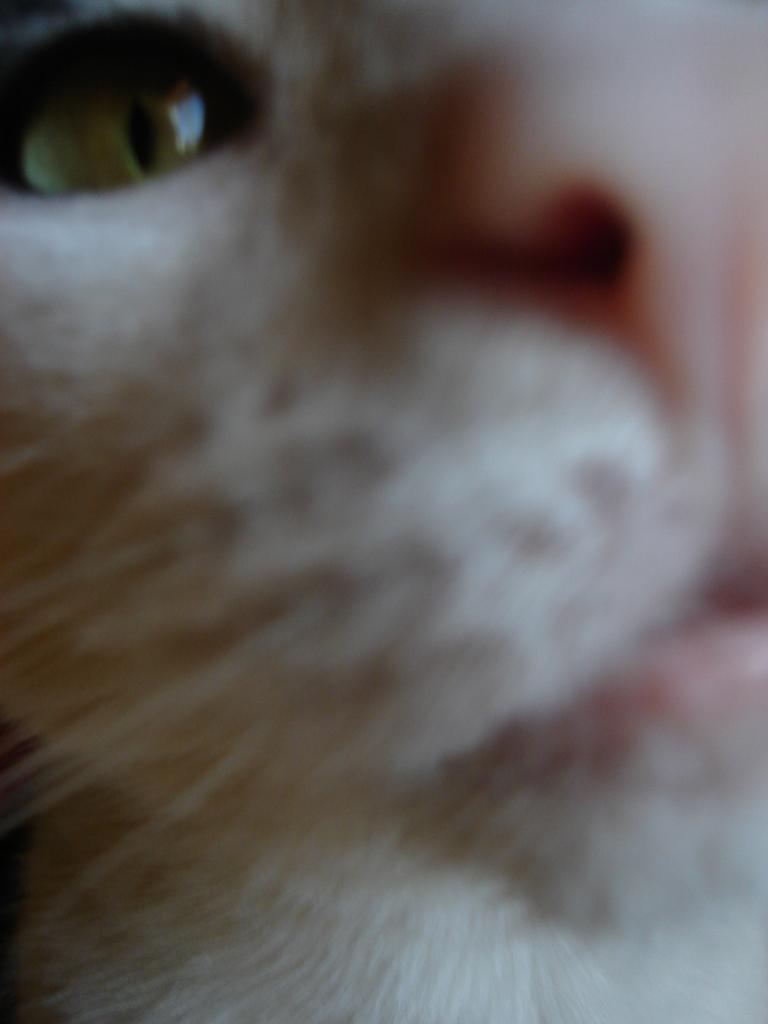Please provide a concise description of this image. In this picture we can see a close view of the white color cat is looking into the camera. 